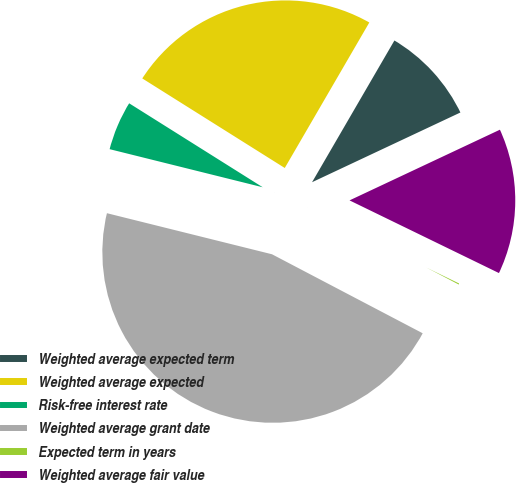Convert chart to OTSL. <chart><loc_0><loc_0><loc_500><loc_500><pie_chart><fcel>Weighted average expected term<fcel>Weighted average expected<fcel>Risk-free interest rate<fcel>Weighted average grant date<fcel>Expected term in years<fcel>Weighted average fair value<nl><fcel>9.63%<fcel>24.45%<fcel>5.05%<fcel>46.2%<fcel>0.48%<fcel>14.2%<nl></chart> 